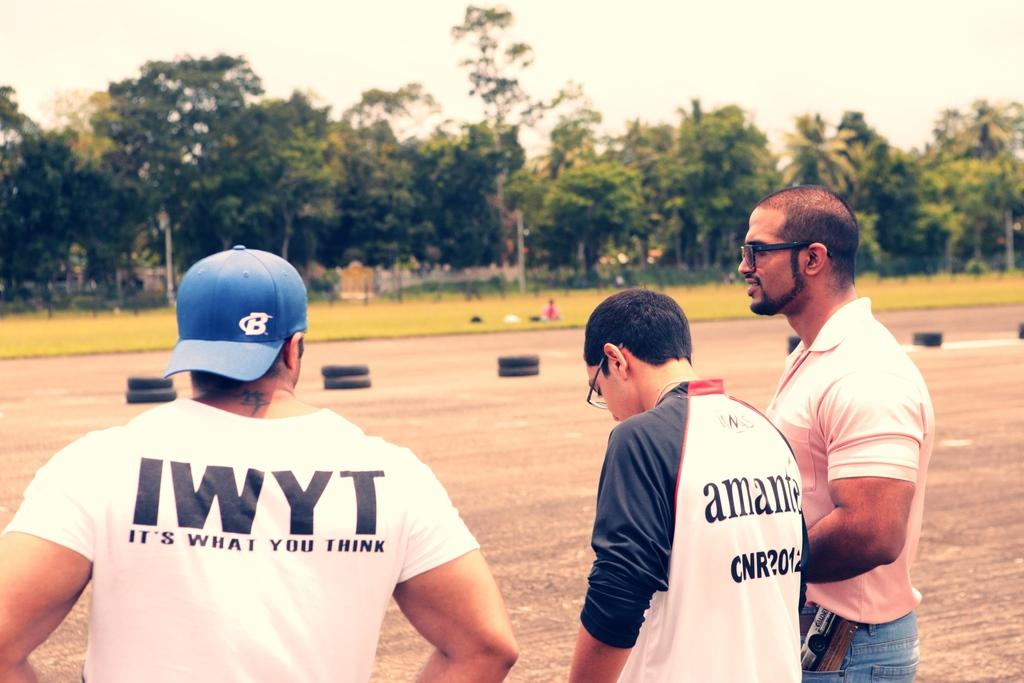<image>
Write a terse but informative summary of the picture. Three men are in a park and one has a IWYT t-shirt on 